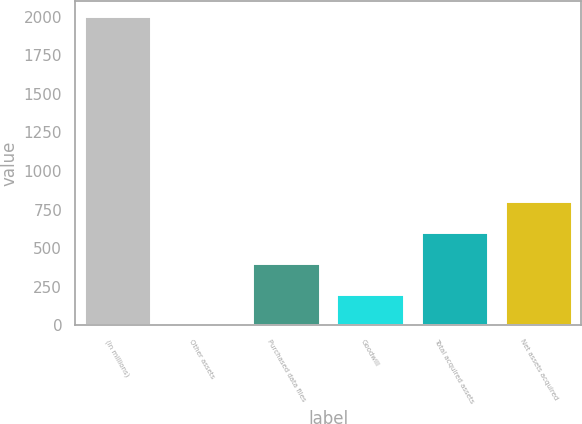Convert chart to OTSL. <chart><loc_0><loc_0><loc_500><loc_500><bar_chart><fcel>(in millions)<fcel>Other assets<fcel>Purchased data files<fcel>Goodwill<fcel>Total acquired assets<fcel>Net assets acquired<nl><fcel>2004<fcel>1.6<fcel>402.08<fcel>201.84<fcel>602.32<fcel>802.56<nl></chart> 